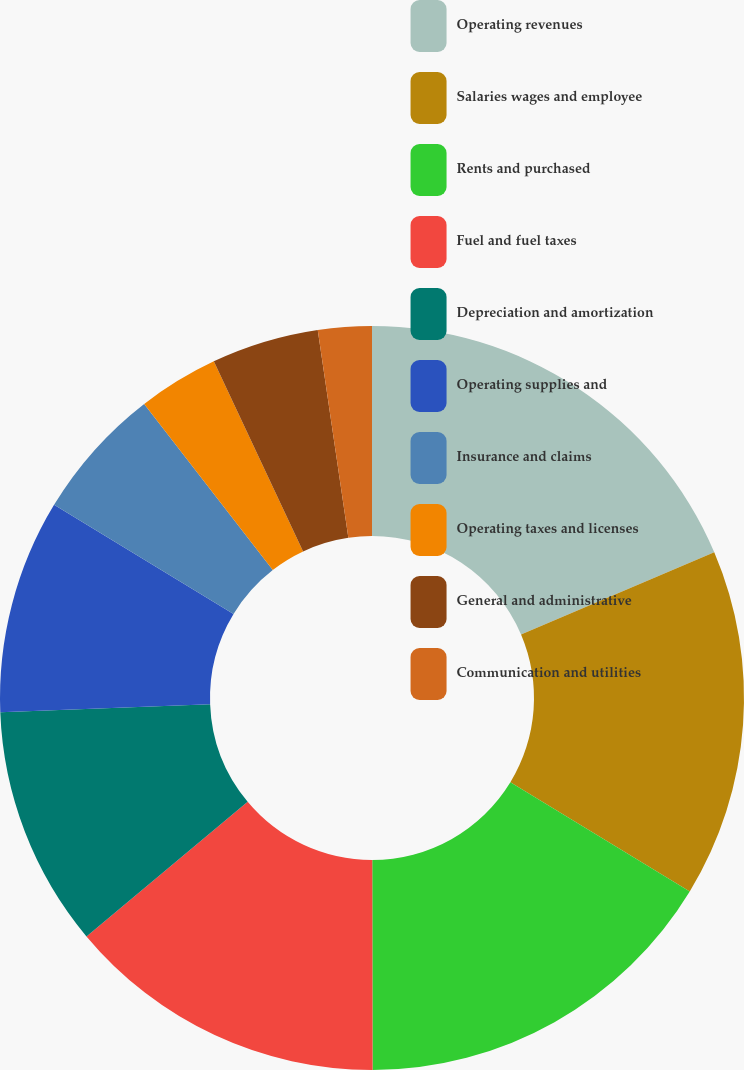<chart> <loc_0><loc_0><loc_500><loc_500><pie_chart><fcel>Operating revenues<fcel>Salaries wages and employee<fcel>Rents and purchased<fcel>Fuel and fuel taxes<fcel>Depreciation and amortization<fcel>Operating supplies and<fcel>Insurance and claims<fcel>Operating taxes and licenses<fcel>General and administrative<fcel>Communication and utilities<nl><fcel>18.59%<fcel>15.11%<fcel>16.27%<fcel>13.95%<fcel>10.46%<fcel>9.3%<fcel>5.82%<fcel>3.5%<fcel>4.66%<fcel>2.33%<nl></chart> 